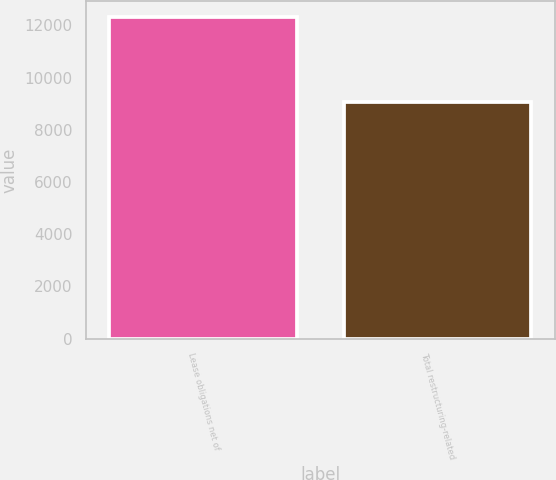<chart> <loc_0><loc_0><loc_500><loc_500><bar_chart><fcel>Lease obligations net of<fcel>Total restructuring-related<nl><fcel>12304<fcel>9047<nl></chart> 